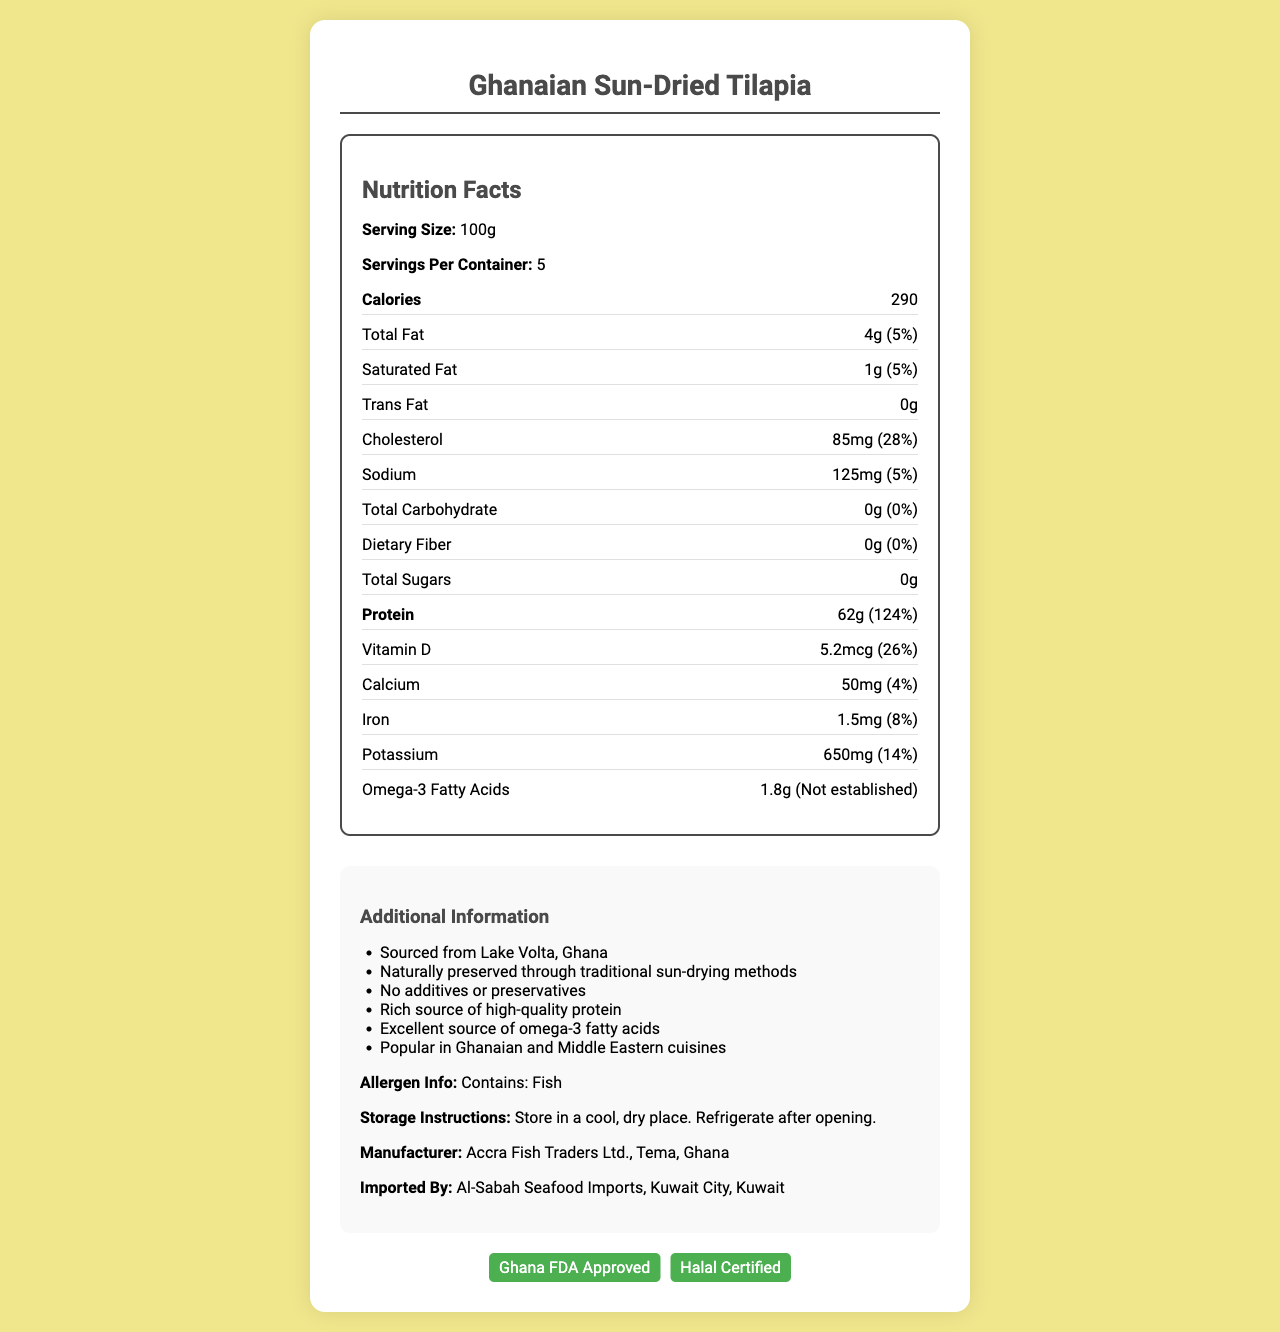What is the serving size of Ghanaian Sun-Dried Tilapia? The serving size is listed as 100g in the nutrition facts section of the document.
Answer: 100g How much protein is in one serving? The protein content per serving is specifically listed as 62g.
Answer: 62g What is the source of the dried fish according to the document? The additional information section states that the fish is sourced from Lake Volta, Ghana.
Answer: Lake Volta, Ghana What certifications does the product have? The certifications are listed at the bottom of the document and include Ghana FDA Approved and Halal Certified.
Answer: Ghana FDA Approved, Halal Certified Does the product contain any dietary fiber? The document shows that the dietary fiber is 0g, indicating the product does not contain any dietary fiber.
Answer: No What is the amount of omega-3 fatty acids per serving? The amount of omega-3 fatty acids per serving is listed as 1.8g in the nutrition facts section.
Answer: 1.8g What is the daily value percentage of saturated fat per serving? A. 5% B. 10% C. 15% D. 20% The daily value percentage of saturated fat per serving is listed as 5%.
Answer: A. 5% Which of the following is a true statement about the Ghanaian Sun-Dried Tilapia? A. It is sourced from the Amazon River. B. It contains preservatives. C. It is an excellent source of omega-3 fatty acids. D. It is high in sugar. The additional information section states that it is an excellent source of omega-3 fatty acids.
Answer: C. It is an excellent source of omega-3 fatty acids. Is the product certified Halal? The certifications section lists that the product is Halal Certified.
Answer: Yes Summarize the main points of the document. The document combines nutritional data with additional information about the product's sourcing, preparation, and certifications, offering a comprehensive overview of the Ghanaian Sun-Dried Tilapia.
Answer: The document provides nutrition facts and additional information about Ghanaian Sun-Dried Tilapia. It highlights the product's serving size, nutrient content (including protein and omega-3 fatty acids), and other important details like allergies, storage instructions, and certifications. Can the exact fishing village where the tilapia was sourced be determined from the document? The document only states that the fish is sourced from Lake Volta, Ghana, but does not specify the exact fishing village.
Answer: Cannot be determined 